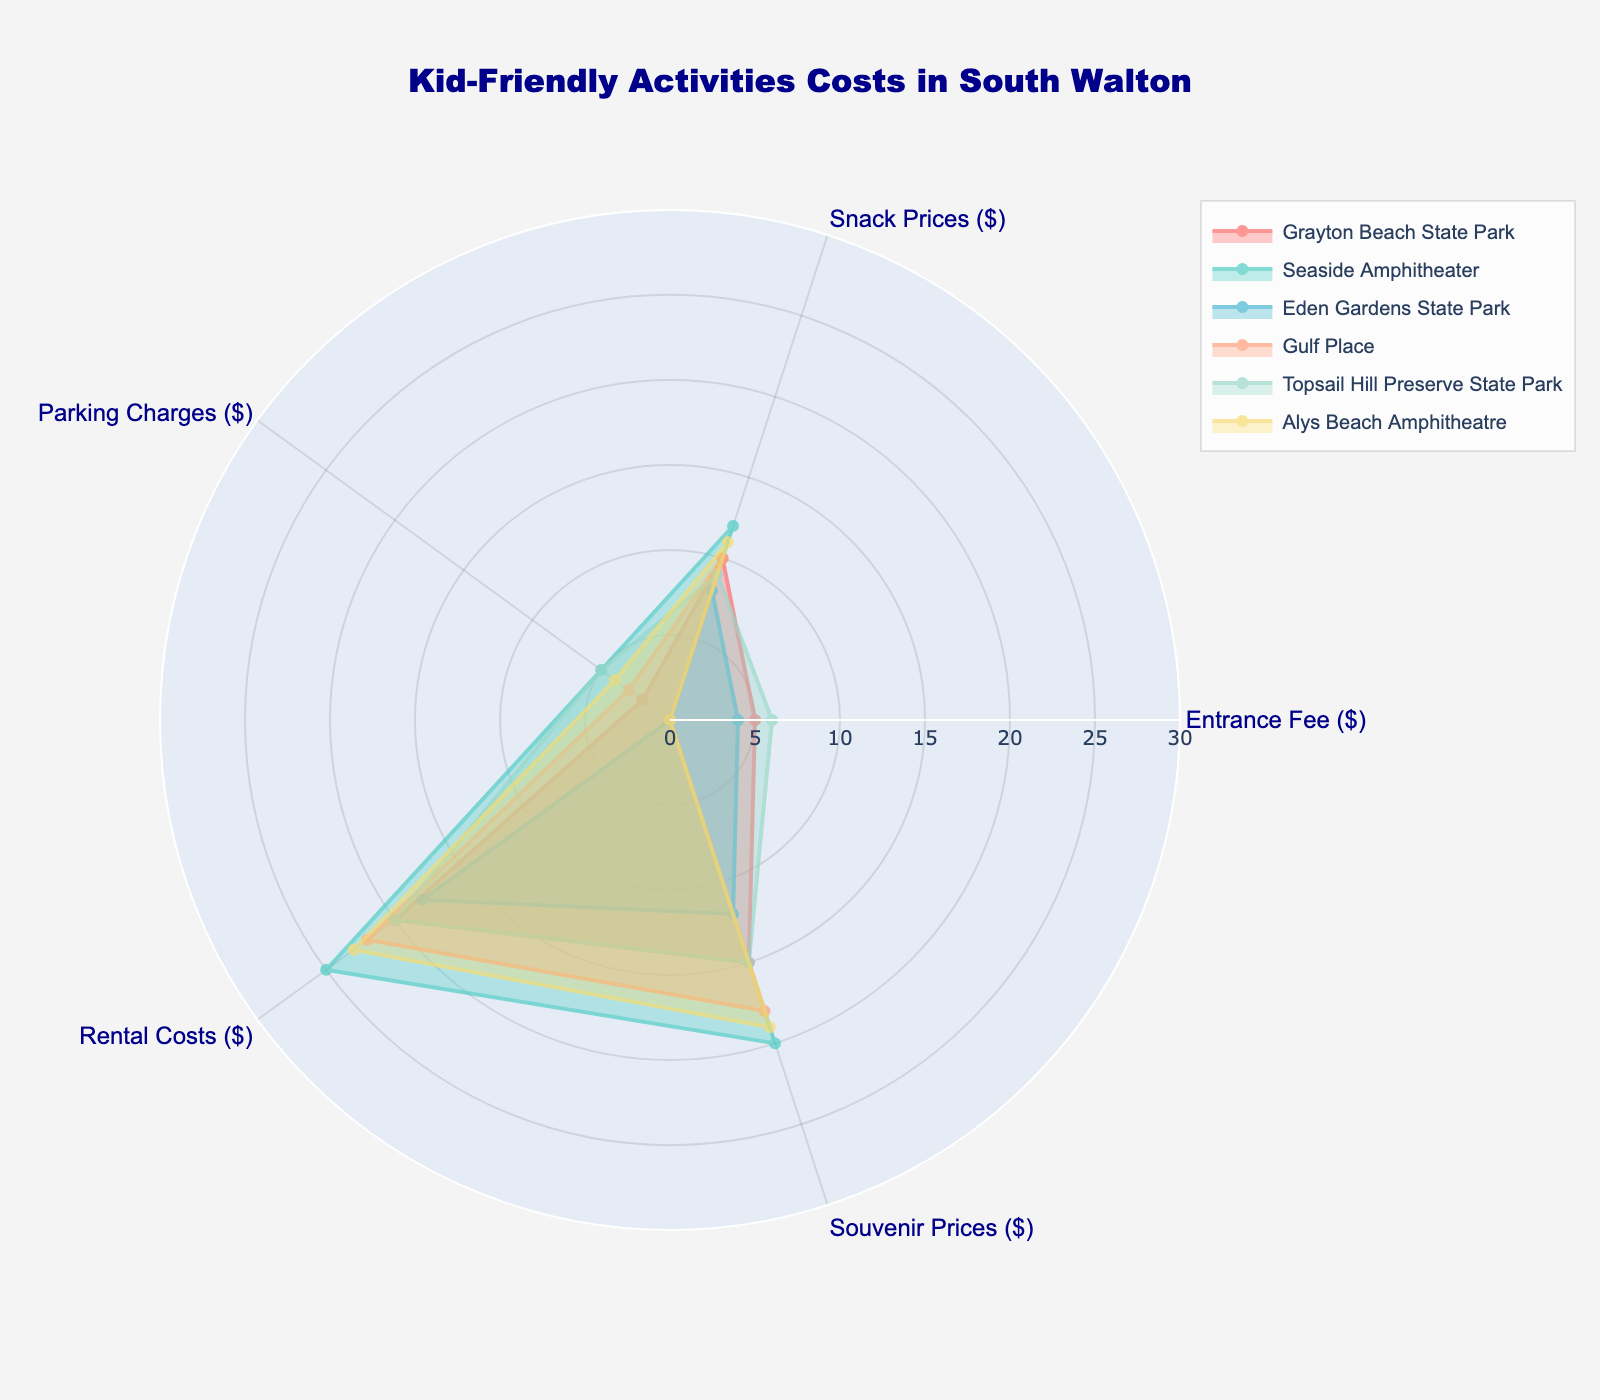What's the title of the figure? At the top of the figure, the title is clearly visible and reads "Kid-Friendly Activities Costs in South Walton".
Answer: Kid-Friendly Activities Costs in South Walton How many categories of costs are compared in this radar chart? Looking at the chart, there are five distinct cost categories shown around the radar chart: Entrance Fee, Snack Prices, Parking Charges, Rental Costs, and Souvenir Prices.
Answer: Five Which destination has the lowest parking charges? Checking the data corresponding to the "Parking Charges" category, Eden Gardens State Park has the lowest value at $0.
Answer: Eden Gardens State Park What is the total cost of kid-friendly activities at Grayton Beach State Park? Summing up the individual costs related to Grayton Beach State Park: Entrance Fee ($5) + Snack Prices ($10) + Parking Charges ($2) + Rental Costs ($20) + Souvenir Prices ($15). The total is 5 + 10 + 2 + 20 + 15 = 52.
Answer: $52 Which destination has the highest snack prices? By observing the "Snack Prices" section, Seaside Amphitheater has the highest at $12.
Answer: Seaside Amphitheater How many destinations have an entrance fee of $0? Reviewing the "Entrance Fee" data, Seaside Amphitheater, Gulf Place, and Alys Beach Amphitheatre have an entrance fee of $0. There are a total of 3 destinations.
Answer: Three Compare the rental costs between Seaside Amphitheater and Topsail Hill Preserve State Park. Which one is higher and by how much? Seaside Amphitheater's rental costs are $25, while Topsail Hill Preserve State Park's rental costs are $20. The difference is 25 - 20 = $5, so Seaside Amphitheater is higher by $5.
Answer: Seaside Amphitheater is higher by $5 Which destination has the most balanced distribution of costs? Looking at the shape of the radar chart for each destination, Gulf Place appears to have the most balanced and consistent values across all categories, without any drastic highs or lows.
Answer: Gulf Place Calculate the average souvenir price across all destinations. Summing the Souvenir Prices (15 + 20 + 12 + 18 + 15 + 19 = 99) and dividing by the total number of destinations (6), the average is 99 / 6 = 16.5.
Answer: $16.5 